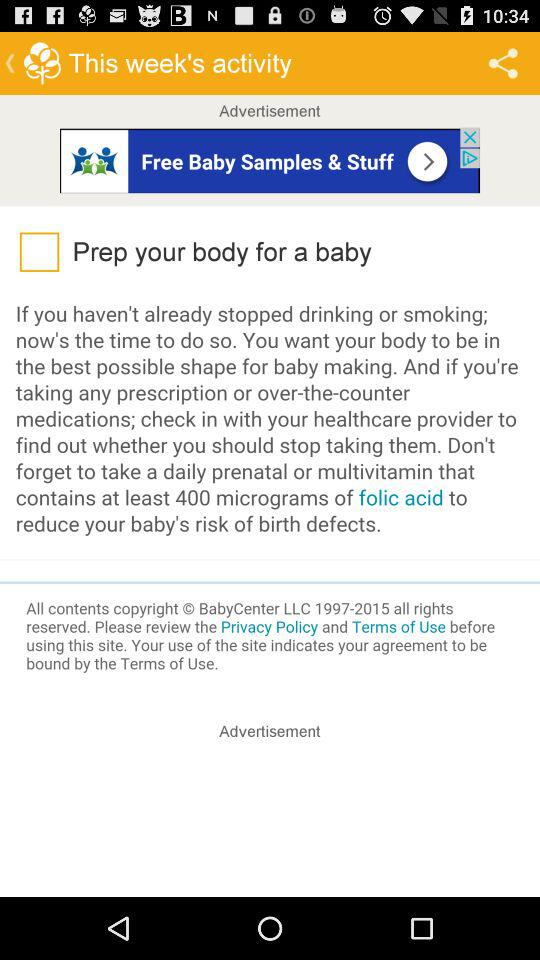How much folic acid is required to reduce the baby's risk of birth defects? To reduce the baby's risk of birth defects, at least 400 micrograms of folic acid are required daily. 